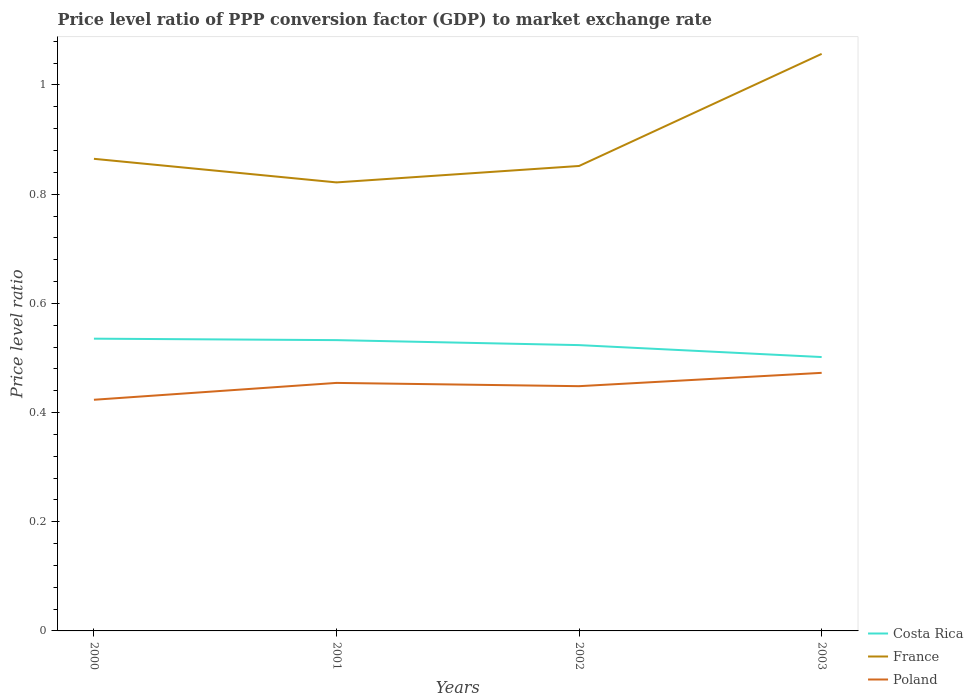Does the line corresponding to Poland intersect with the line corresponding to Costa Rica?
Ensure brevity in your answer.  No. Across all years, what is the maximum price level ratio in France?
Your response must be concise. 0.82. What is the total price level ratio in France in the graph?
Keep it short and to the point. 0.04. What is the difference between the highest and the second highest price level ratio in Costa Rica?
Offer a very short reply. 0.03. What is the difference between the highest and the lowest price level ratio in Poland?
Keep it short and to the point. 2. How many years are there in the graph?
Your answer should be very brief. 4. Are the values on the major ticks of Y-axis written in scientific E-notation?
Keep it short and to the point. No. Does the graph contain any zero values?
Your answer should be compact. No. How many legend labels are there?
Your answer should be very brief. 3. How are the legend labels stacked?
Your answer should be compact. Vertical. What is the title of the graph?
Your answer should be very brief. Price level ratio of PPP conversion factor (GDP) to market exchange rate. Does "Saudi Arabia" appear as one of the legend labels in the graph?
Ensure brevity in your answer.  No. What is the label or title of the Y-axis?
Offer a very short reply. Price level ratio. What is the Price level ratio of Costa Rica in 2000?
Your response must be concise. 0.54. What is the Price level ratio in France in 2000?
Your answer should be compact. 0.86. What is the Price level ratio of Poland in 2000?
Provide a succinct answer. 0.42. What is the Price level ratio in Costa Rica in 2001?
Make the answer very short. 0.53. What is the Price level ratio of France in 2001?
Offer a very short reply. 0.82. What is the Price level ratio of Poland in 2001?
Offer a terse response. 0.45. What is the Price level ratio in Costa Rica in 2002?
Your answer should be very brief. 0.52. What is the Price level ratio in France in 2002?
Your answer should be compact. 0.85. What is the Price level ratio in Poland in 2002?
Make the answer very short. 0.45. What is the Price level ratio in Costa Rica in 2003?
Ensure brevity in your answer.  0.5. What is the Price level ratio of France in 2003?
Your answer should be very brief. 1.06. What is the Price level ratio of Poland in 2003?
Provide a succinct answer. 0.47. Across all years, what is the maximum Price level ratio in Costa Rica?
Offer a terse response. 0.54. Across all years, what is the maximum Price level ratio in France?
Make the answer very short. 1.06. Across all years, what is the maximum Price level ratio of Poland?
Provide a succinct answer. 0.47. Across all years, what is the minimum Price level ratio in Costa Rica?
Your answer should be compact. 0.5. Across all years, what is the minimum Price level ratio of France?
Offer a very short reply. 0.82. Across all years, what is the minimum Price level ratio in Poland?
Provide a short and direct response. 0.42. What is the total Price level ratio of Costa Rica in the graph?
Your answer should be compact. 2.09. What is the total Price level ratio of France in the graph?
Give a very brief answer. 3.59. What is the total Price level ratio in Poland in the graph?
Ensure brevity in your answer.  1.8. What is the difference between the Price level ratio of Costa Rica in 2000 and that in 2001?
Provide a short and direct response. 0. What is the difference between the Price level ratio of France in 2000 and that in 2001?
Offer a terse response. 0.04. What is the difference between the Price level ratio in Poland in 2000 and that in 2001?
Offer a terse response. -0.03. What is the difference between the Price level ratio in Costa Rica in 2000 and that in 2002?
Provide a short and direct response. 0.01. What is the difference between the Price level ratio in France in 2000 and that in 2002?
Your answer should be compact. 0.01. What is the difference between the Price level ratio of Poland in 2000 and that in 2002?
Offer a terse response. -0.02. What is the difference between the Price level ratio of Costa Rica in 2000 and that in 2003?
Provide a short and direct response. 0.03. What is the difference between the Price level ratio in France in 2000 and that in 2003?
Make the answer very short. -0.19. What is the difference between the Price level ratio in Poland in 2000 and that in 2003?
Give a very brief answer. -0.05. What is the difference between the Price level ratio in Costa Rica in 2001 and that in 2002?
Give a very brief answer. 0.01. What is the difference between the Price level ratio in France in 2001 and that in 2002?
Give a very brief answer. -0.03. What is the difference between the Price level ratio in Poland in 2001 and that in 2002?
Offer a very short reply. 0.01. What is the difference between the Price level ratio in Costa Rica in 2001 and that in 2003?
Offer a very short reply. 0.03. What is the difference between the Price level ratio in France in 2001 and that in 2003?
Make the answer very short. -0.24. What is the difference between the Price level ratio of Poland in 2001 and that in 2003?
Offer a terse response. -0.02. What is the difference between the Price level ratio in Costa Rica in 2002 and that in 2003?
Keep it short and to the point. 0.02. What is the difference between the Price level ratio in France in 2002 and that in 2003?
Provide a succinct answer. -0.21. What is the difference between the Price level ratio in Poland in 2002 and that in 2003?
Make the answer very short. -0.02. What is the difference between the Price level ratio in Costa Rica in 2000 and the Price level ratio in France in 2001?
Your answer should be very brief. -0.29. What is the difference between the Price level ratio of Costa Rica in 2000 and the Price level ratio of Poland in 2001?
Provide a short and direct response. 0.08. What is the difference between the Price level ratio of France in 2000 and the Price level ratio of Poland in 2001?
Your response must be concise. 0.41. What is the difference between the Price level ratio of Costa Rica in 2000 and the Price level ratio of France in 2002?
Offer a very short reply. -0.32. What is the difference between the Price level ratio in Costa Rica in 2000 and the Price level ratio in Poland in 2002?
Make the answer very short. 0.09. What is the difference between the Price level ratio of France in 2000 and the Price level ratio of Poland in 2002?
Offer a very short reply. 0.42. What is the difference between the Price level ratio in Costa Rica in 2000 and the Price level ratio in France in 2003?
Your response must be concise. -0.52. What is the difference between the Price level ratio of Costa Rica in 2000 and the Price level ratio of Poland in 2003?
Give a very brief answer. 0.06. What is the difference between the Price level ratio of France in 2000 and the Price level ratio of Poland in 2003?
Keep it short and to the point. 0.39. What is the difference between the Price level ratio of Costa Rica in 2001 and the Price level ratio of France in 2002?
Make the answer very short. -0.32. What is the difference between the Price level ratio of Costa Rica in 2001 and the Price level ratio of Poland in 2002?
Ensure brevity in your answer.  0.08. What is the difference between the Price level ratio in France in 2001 and the Price level ratio in Poland in 2002?
Offer a terse response. 0.37. What is the difference between the Price level ratio in Costa Rica in 2001 and the Price level ratio in France in 2003?
Your answer should be very brief. -0.52. What is the difference between the Price level ratio in Costa Rica in 2001 and the Price level ratio in Poland in 2003?
Your response must be concise. 0.06. What is the difference between the Price level ratio in France in 2001 and the Price level ratio in Poland in 2003?
Your response must be concise. 0.35. What is the difference between the Price level ratio of Costa Rica in 2002 and the Price level ratio of France in 2003?
Keep it short and to the point. -0.53. What is the difference between the Price level ratio of Costa Rica in 2002 and the Price level ratio of Poland in 2003?
Offer a very short reply. 0.05. What is the difference between the Price level ratio of France in 2002 and the Price level ratio of Poland in 2003?
Give a very brief answer. 0.38. What is the average Price level ratio of Costa Rica per year?
Your answer should be compact. 0.52. What is the average Price level ratio of France per year?
Make the answer very short. 0.9. What is the average Price level ratio of Poland per year?
Ensure brevity in your answer.  0.45. In the year 2000, what is the difference between the Price level ratio in Costa Rica and Price level ratio in France?
Make the answer very short. -0.33. In the year 2000, what is the difference between the Price level ratio of Costa Rica and Price level ratio of Poland?
Provide a succinct answer. 0.11. In the year 2000, what is the difference between the Price level ratio in France and Price level ratio in Poland?
Keep it short and to the point. 0.44. In the year 2001, what is the difference between the Price level ratio of Costa Rica and Price level ratio of France?
Keep it short and to the point. -0.29. In the year 2001, what is the difference between the Price level ratio in Costa Rica and Price level ratio in Poland?
Your response must be concise. 0.08. In the year 2001, what is the difference between the Price level ratio of France and Price level ratio of Poland?
Offer a very short reply. 0.37. In the year 2002, what is the difference between the Price level ratio in Costa Rica and Price level ratio in France?
Provide a short and direct response. -0.33. In the year 2002, what is the difference between the Price level ratio in Costa Rica and Price level ratio in Poland?
Offer a terse response. 0.08. In the year 2002, what is the difference between the Price level ratio of France and Price level ratio of Poland?
Provide a succinct answer. 0.4. In the year 2003, what is the difference between the Price level ratio in Costa Rica and Price level ratio in France?
Your response must be concise. -0.56. In the year 2003, what is the difference between the Price level ratio in Costa Rica and Price level ratio in Poland?
Offer a terse response. 0.03. In the year 2003, what is the difference between the Price level ratio of France and Price level ratio of Poland?
Give a very brief answer. 0.58. What is the ratio of the Price level ratio in France in 2000 to that in 2001?
Offer a very short reply. 1.05. What is the ratio of the Price level ratio in Poland in 2000 to that in 2001?
Give a very brief answer. 0.93. What is the ratio of the Price level ratio of Costa Rica in 2000 to that in 2002?
Your response must be concise. 1.02. What is the ratio of the Price level ratio of France in 2000 to that in 2002?
Give a very brief answer. 1.02. What is the ratio of the Price level ratio in Poland in 2000 to that in 2002?
Provide a succinct answer. 0.94. What is the ratio of the Price level ratio in Costa Rica in 2000 to that in 2003?
Provide a short and direct response. 1.07. What is the ratio of the Price level ratio of France in 2000 to that in 2003?
Offer a terse response. 0.82. What is the ratio of the Price level ratio of Poland in 2000 to that in 2003?
Your answer should be compact. 0.9. What is the ratio of the Price level ratio in Costa Rica in 2001 to that in 2002?
Make the answer very short. 1.02. What is the ratio of the Price level ratio in France in 2001 to that in 2002?
Offer a very short reply. 0.96. What is the ratio of the Price level ratio in Poland in 2001 to that in 2002?
Provide a short and direct response. 1.01. What is the ratio of the Price level ratio of Costa Rica in 2001 to that in 2003?
Ensure brevity in your answer.  1.06. What is the ratio of the Price level ratio of France in 2001 to that in 2003?
Your answer should be compact. 0.78. What is the ratio of the Price level ratio in Poland in 2001 to that in 2003?
Provide a short and direct response. 0.96. What is the ratio of the Price level ratio in Costa Rica in 2002 to that in 2003?
Make the answer very short. 1.04. What is the ratio of the Price level ratio of France in 2002 to that in 2003?
Your answer should be very brief. 0.81. What is the ratio of the Price level ratio in Poland in 2002 to that in 2003?
Provide a succinct answer. 0.95. What is the difference between the highest and the second highest Price level ratio in Costa Rica?
Give a very brief answer. 0. What is the difference between the highest and the second highest Price level ratio in France?
Give a very brief answer. 0.19. What is the difference between the highest and the second highest Price level ratio of Poland?
Keep it short and to the point. 0.02. What is the difference between the highest and the lowest Price level ratio of Costa Rica?
Make the answer very short. 0.03. What is the difference between the highest and the lowest Price level ratio in France?
Your response must be concise. 0.24. What is the difference between the highest and the lowest Price level ratio in Poland?
Your answer should be compact. 0.05. 